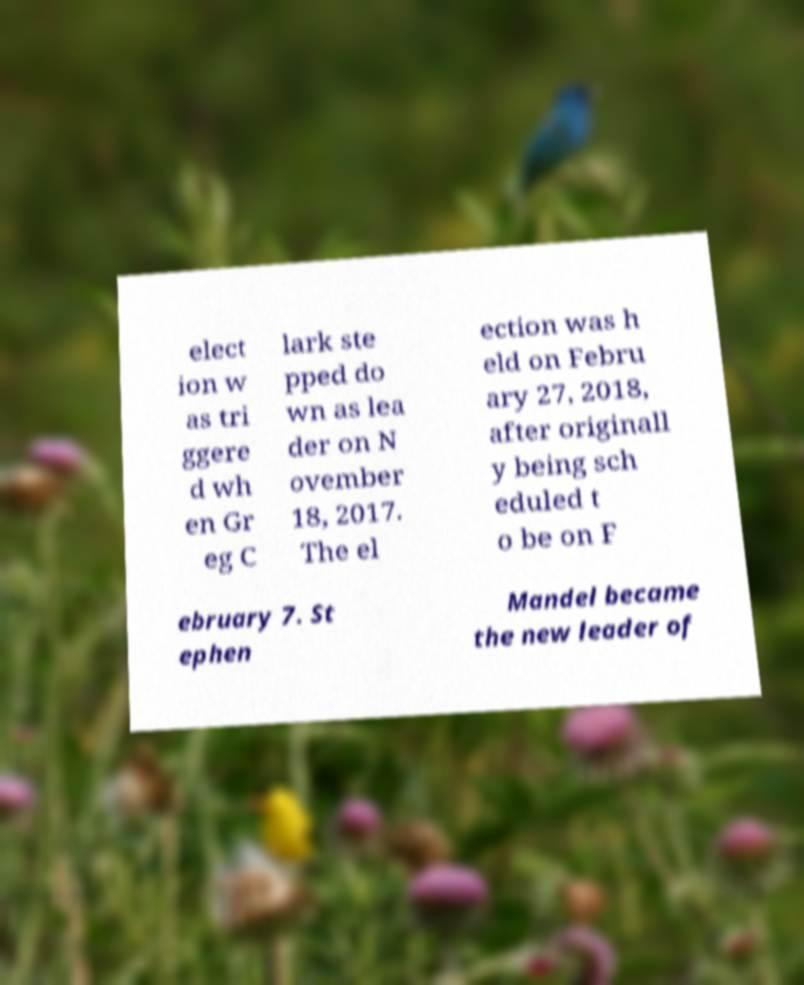For documentation purposes, I need the text within this image transcribed. Could you provide that? elect ion w as tri ggere d wh en Gr eg C lark ste pped do wn as lea der on N ovember 18, 2017. The el ection was h eld on Febru ary 27, 2018, after originall y being sch eduled t o be on F ebruary 7. St ephen Mandel became the new leader of 